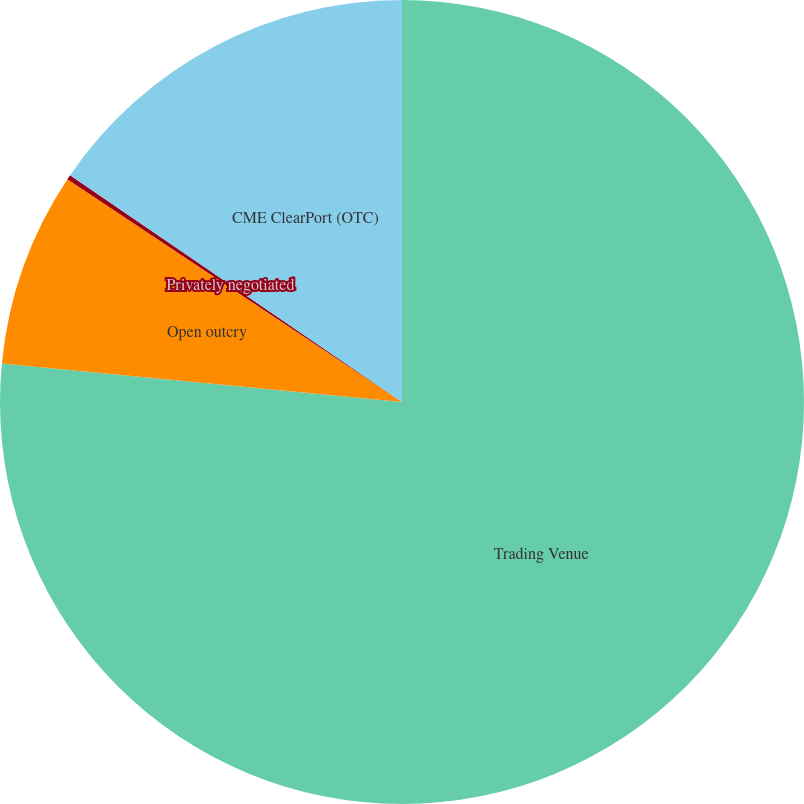Convert chart to OTSL. <chart><loc_0><loc_0><loc_500><loc_500><pie_chart><fcel>Trading Venue<fcel>Open outcry<fcel>Privately negotiated<fcel>CME ClearPort (OTC)<nl><fcel>76.53%<fcel>7.82%<fcel>0.19%<fcel>15.46%<nl></chart> 